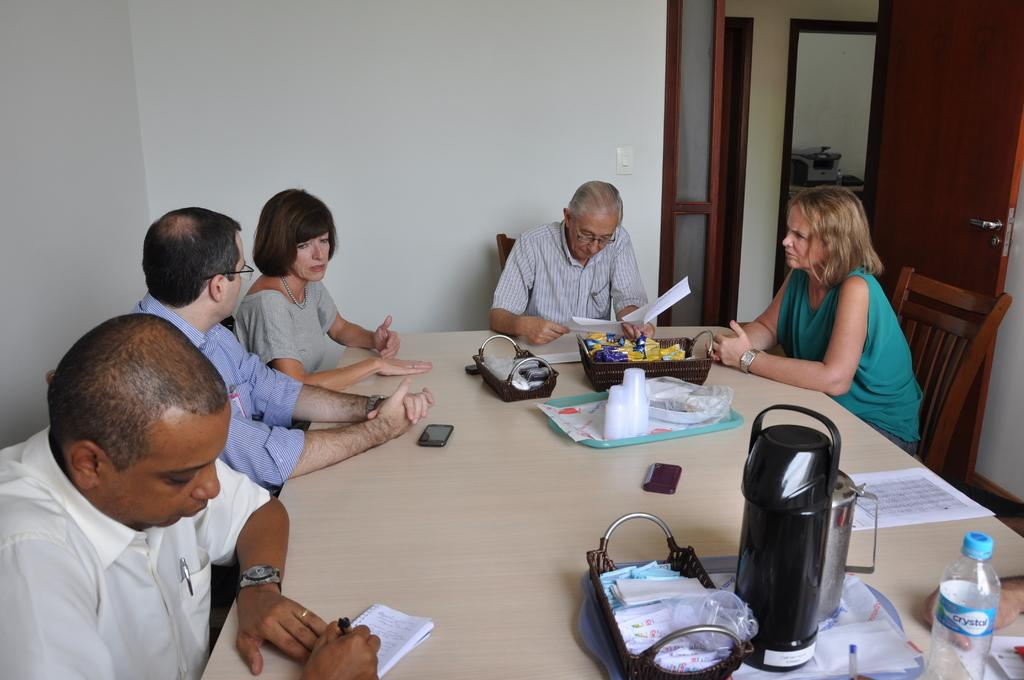What is happening with the group of people in the image? The people in the image are seated on chairs. What are two activities being performed by the people in the image? There is a man writing and a man reading in the image. What items can be seen on the table in the image? There are bottles, papers, and a cup on the table. What type of stamp is being used by the man writing in the image? There is no stamp present in the image; the man is simply writing with a pen or pencil. 